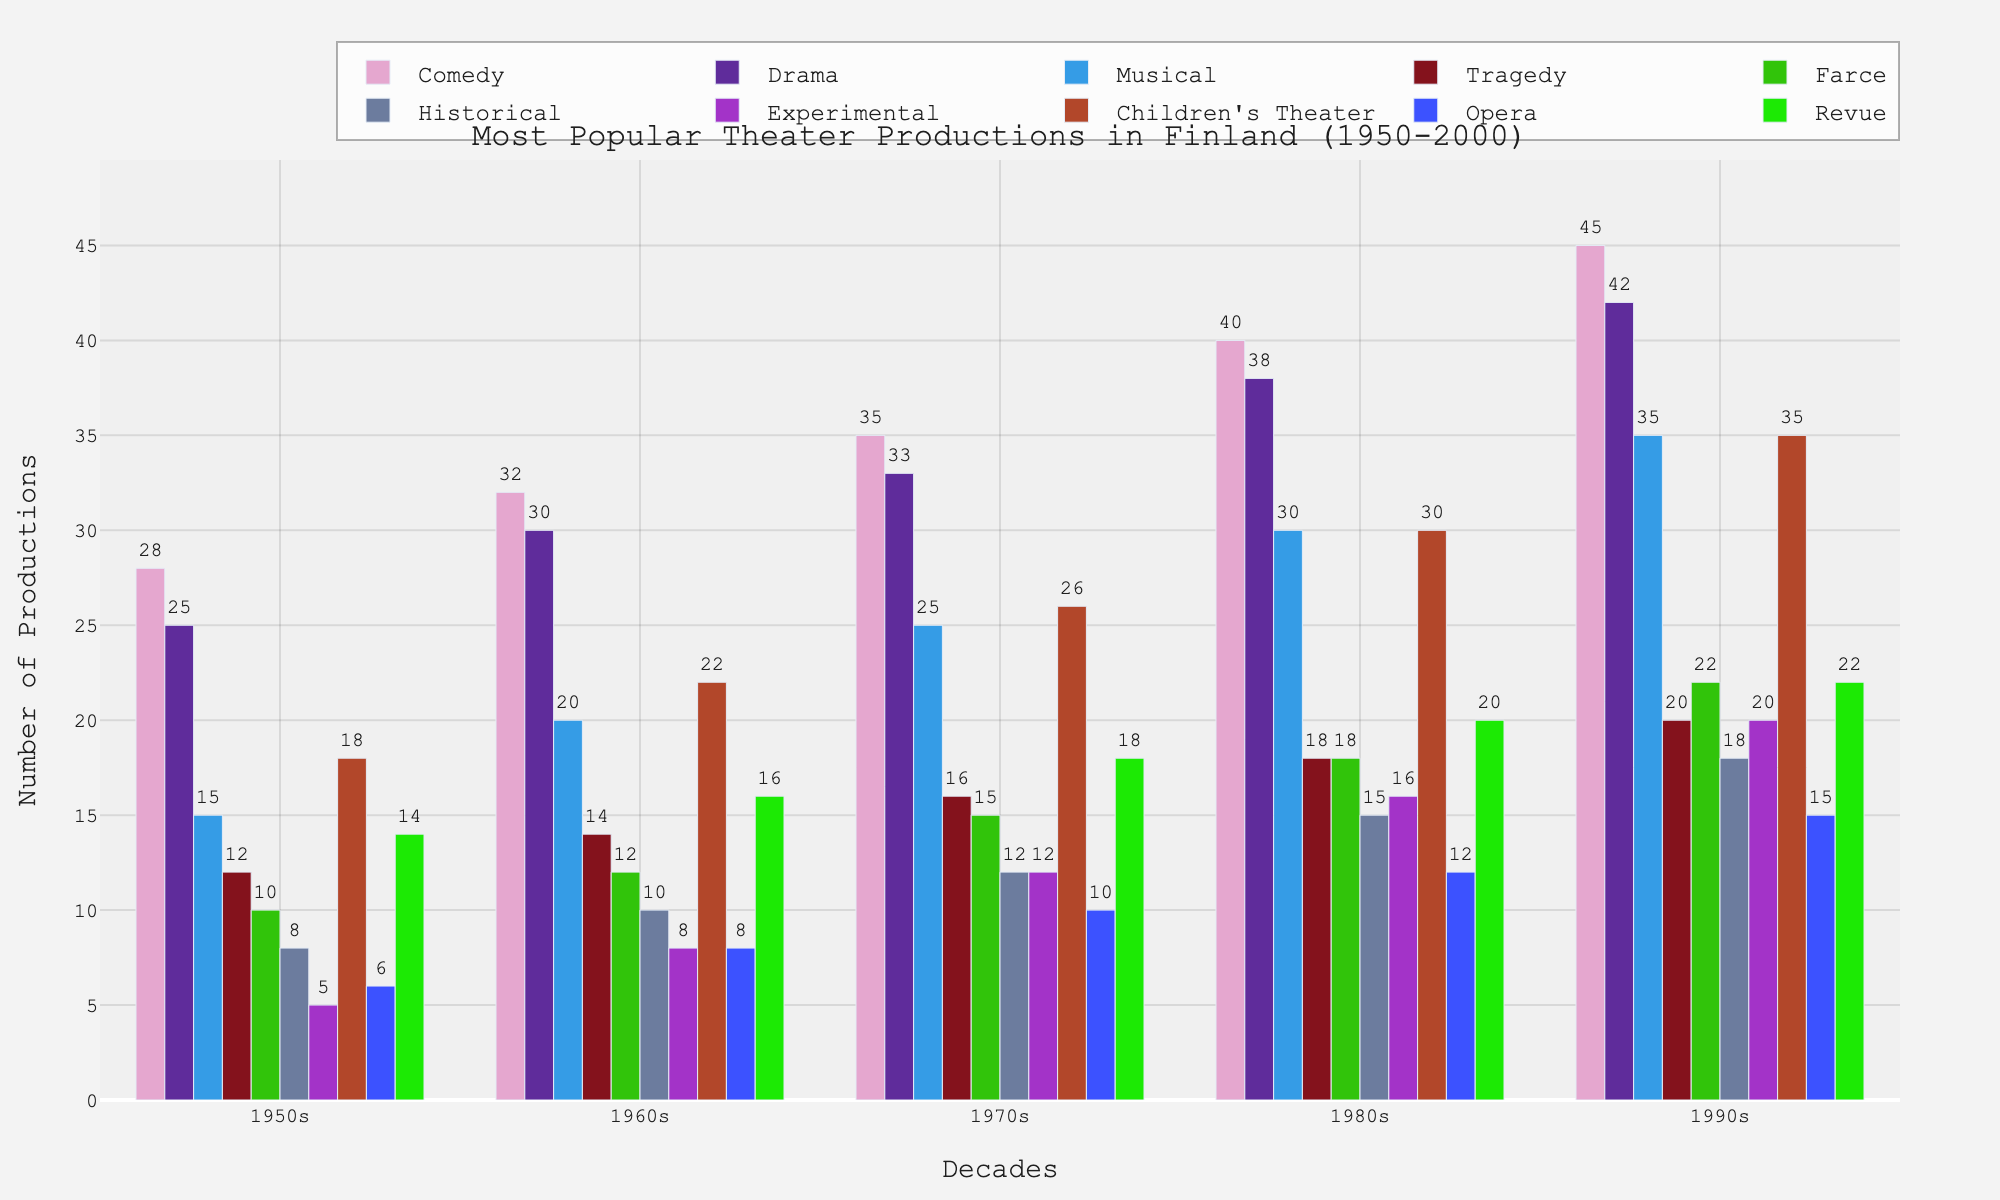Which genre had the highest number of productions in the 1990s? Looking at the bar heights for the 1990s, Comedy had the longest bar, indicating the highest number of productions.
Answer: Comedy How many more Comedy productions were there in the 1980s compared to Farce? From the figure, Comedy had 40 productions and Farce had 18 productions in the 1980s. The difference is 40 - 18 = 22.
Answer: 22 Which genre shows the most significant increase in productions from the 1950s to the 1990s? By comparing the bar lengths from the 1950s to the 1990s for each genre, we see Comedy increased from 28 to 45, Drama from 25 to 42, etc. Comedy shows the largest increase by 45 - 28 = 17.
Answer: Comedy What is the combined total number of Musical and Opera productions in the 1970s? According to the chart, Musical had 25 productions and Opera had 10 productions in the 1970s. Adding these gives 25 + 10 = 35.
Answer: 35 In which decade did Children’s Theater see the highest number of productions? Upon reviewing the various decades, Children's Theater had the highest bar in the 1990s with 35 productions.
Answer: 1990s How does the number of Experimental productions in the 1980s compare to Historical productions in the same decade? The chart shows that Experimental had 16 productions while Historical had 15 in the 1980s. Thus, Experimental had 1 more production than Historical.
Answer: Experimental had 1 more Which genre had the lowest number of productions in the 1950s and what was the number? In the figure, Experimental has the shortest bar in the 1950s with 5 productions.
Answer: Experimental, 5 What is the average number of Revue productions per decade from the 1950s to 1990s? Summing the Revue values (14 + 16 + 18 + 20 + 22) gives 90, and there are 5 decades. The average is 90 / 5 = 18.
Answer: 18 Among the genres listed, which showed a steady increase in the number of productions every decade? Observing the bars, Comedy, Drama, Musical, Tragedy, Farce, Historical, Experimental, Children's Theater, and Revue all show a steady increase in each decade.
Answer: Multiple genres (Comedy, Drama, Musical, Tragedy, Farce, Historical, Experimental, Children's Theater, Revue) What was the relative growth rate of Drama productions from the 1950s to the 1990s? Drama increased from 25 productions in the 1950s to 42 in the 1990s. Relative growth rate is calculated as (42 - 25) / 25 = 0.68 or 68%.
Answer: 68% 